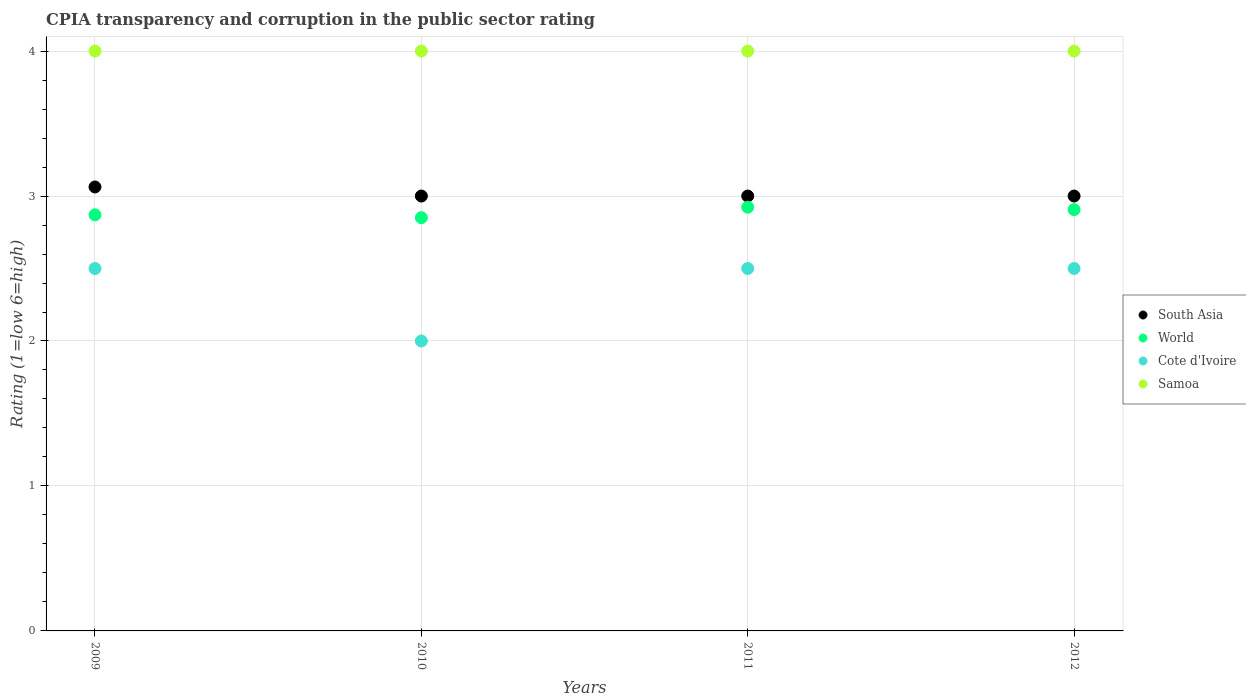What is the CPIA rating in World in 2010?
Your answer should be compact. 2.85. Across all years, what is the maximum CPIA rating in Samoa?
Ensure brevity in your answer.  4. Across all years, what is the minimum CPIA rating in World?
Make the answer very short. 2.85. What is the total CPIA rating in Samoa in the graph?
Your answer should be compact. 16. What is the difference between the CPIA rating in South Asia in 2009 and that in 2012?
Your response must be concise. 0.06. What is the difference between the CPIA rating in South Asia in 2010 and the CPIA rating in World in 2009?
Offer a terse response. 0.13. In the year 2012, what is the difference between the CPIA rating in World and CPIA rating in Cote d'Ivoire?
Your answer should be compact. 0.41. Is the CPIA rating in World in 2009 less than that in 2010?
Your answer should be very brief. No. What is the difference between the highest and the lowest CPIA rating in World?
Offer a terse response. 0.07. In how many years, is the CPIA rating in Cote d'Ivoire greater than the average CPIA rating in Cote d'Ivoire taken over all years?
Offer a very short reply. 3. Is it the case that in every year, the sum of the CPIA rating in Samoa and CPIA rating in World  is greater than the sum of CPIA rating in South Asia and CPIA rating in Cote d'Ivoire?
Ensure brevity in your answer.  Yes. Does the CPIA rating in South Asia monotonically increase over the years?
Offer a very short reply. No. Is the CPIA rating in World strictly greater than the CPIA rating in Cote d'Ivoire over the years?
Provide a succinct answer. Yes. Are the values on the major ticks of Y-axis written in scientific E-notation?
Make the answer very short. No. Does the graph contain any zero values?
Keep it short and to the point. No. What is the title of the graph?
Make the answer very short. CPIA transparency and corruption in the public sector rating. Does "Mongolia" appear as one of the legend labels in the graph?
Provide a succinct answer. No. What is the label or title of the X-axis?
Provide a short and direct response. Years. What is the Rating (1=low 6=high) of South Asia in 2009?
Offer a terse response. 3.06. What is the Rating (1=low 6=high) in World in 2009?
Your answer should be compact. 2.87. What is the Rating (1=low 6=high) of Cote d'Ivoire in 2009?
Ensure brevity in your answer.  2.5. What is the Rating (1=low 6=high) in Samoa in 2009?
Provide a short and direct response. 4. What is the Rating (1=low 6=high) in World in 2010?
Make the answer very short. 2.85. What is the Rating (1=low 6=high) in Samoa in 2010?
Your response must be concise. 4. What is the Rating (1=low 6=high) of World in 2011?
Offer a terse response. 2.92. What is the Rating (1=low 6=high) in Cote d'Ivoire in 2011?
Your response must be concise. 2.5. What is the Rating (1=low 6=high) in South Asia in 2012?
Keep it short and to the point. 3. What is the Rating (1=low 6=high) of World in 2012?
Give a very brief answer. 2.91. What is the Rating (1=low 6=high) of Samoa in 2012?
Offer a terse response. 4. Across all years, what is the maximum Rating (1=low 6=high) in South Asia?
Provide a succinct answer. 3.06. Across all years, what is the maximum Rating (1=low 6=high) of World?
Give a very brief answer. 2.92. Across all years, what is the maximum Rating (1=low 6=high) in Cote d'Ivoire?
Give a very brief answer. 2.5. Across all years, what is the minimum Rating (1=low 6=high) of World?
Your response must be concise. 2.85. What is the total Rating (1=low 6=high) in South Asia in the graph?
Offer a very short reply. 12.06. What is the total Rating (1=low 6=high) in World in the graph?
Ensure brevity in your answer.  11.55. What is the total Rating (1=low 6=high) in Cote d'Ivoire in the graph?
Keep it short and to the point. 9.5. What is the total Rating (1=low 6=high) of Samoa in the graph?
Your response must be concise. 16. What is the difference between the Rating (1=low 6=high) of South Asia in 2009 and that in 2010?
Give a very brief answer. 0.06. What is the difference between the Rating (1=low 6=high) of World in 2009 and that in 2010?
Make the answer very short. 0.02. What is the difference between the Rating (1=low 6=high) in Cote d'Ivoire in 2009 and that in 2010?
Give a very brief answer. 0.5. What is the difference between the Rating (1=low 6=high) of South Asia in 2009 and that in 2011?
Make the answer very short. 0.06. What is the difference between the Rating (1=low 6=high) in World in 2009 and that in 2011?
Provide a short and direct response. -0.05. What is the difference between the Rating (1=low 6=high) of South Asia in 2009 and that in 2012?
Make the answer very short. 0.06. What is the difference between the Rating (1=low 6=high) in World in 2009 and that in 2012?
Offer a terse response. -0.04. What is the difference between the Rating (1=low 6=high) of Samoa in 2009 and that in 2012?
Ensure brevity in your answer.  0. What is the difference between the Rating (1=low 6=high) in World in 2010 and that in 2011?
Your response must be concise. -0.07. What is the difference between the Rating (1=low 6=high) in Cote d'Ivoire in 2010 and that in 2011?
Offer a terse response. -0.5. What is the difference between the Rating (1=low 6=high) of South Asia in 2010 and that in 2012?
Your answer should be very brief. 0. What is the difference between the Rating (1=low 6=high) of World in 2010 and that in 2012?
Your answer should be compact. -0.06. What is the difference between the Rating (1=low 6=high) of World in 2011 and that in 2012?
Provide a short and direct response. 0.02. What is the difference between the Rating (1=low 6=high) in South Asia in 2009 and the Rating (1=low 6=high) in World in 2010?
Offer a very short reply. 0.21. What is the difference between the Rating (1=low 6=high) in South Asia in 2009 and the Rating (1=low 6=high) in Samoa in 2010?
Your answer should be very brief. -0.94. What is the difference between the Rating (1=low 6=high) in World in 2009 and the Rating (1=low 6=high) in Cote d'Ivoire in 2010?
Offer a terse response. 0.87. What is the difference between the Rating (1=low 6=high) in World in 2009 and the Rating (1=low 6=high) in Samoa in 2010?
Offer a very short reply. -1.13. What is the difference between the Rating (1=low 6=high) in South Asia in 2009 and the Rating (1=low 6=high) in World in 2011?
Offer a terse response. 0.14. What is the difference between the Rating (1=low 6=high) in South Asia in 2009 and the Rating (1=low 6=high) in Cote d'Ivoire in 2011?
Provide a short and direct response. 0.56. What is the difference between the Rating (1=low 6=high) in South Asia in 2009 and the Rating (1=low 6=high) in Samoa in 2011?
Provide a short and direct response. -0.94. What is the difference between the Rating (1=low 6=high) of World in 2009 and the Rating (1=low 6=high) of Cote d'Ivoire in 2011?
Provide a succinct answer. 0.37. What is the difference between the Rating (1=low 6=high) of World in 2009 and the Rating (1=low 6=high) of Samoa in 2011?
Provide a short and direct response. -1.13. What is the difference between the Rating (1=low 6=high) of Cote d'Ivoire in 2009 and the Rating (1=low 6=high) of Samoa in 2011?
Offer a very short reply. -1.5. What is the difference between the Rating (1=low 6=high) of South Asia in 2009 and the Rating (1=low 6=high) of World in 2012?
Provide a short and direct response. 0.16. What is the difference between the Rating (1=low 6=high) in South Asia in 2009 and the Rating (1=low 6=high) in Cote d'Ivoire in 2012?
Your answer should be very brief. 0.56. What is the difference between the Rating (1=low 6=high) in South Asia in 2009 and the Rating (1=low 6=high) in Samoa in 2012?
Provide a succinct answer. -0.94. What is the difference between the Rating (1=low 6=high) in World in 2009 and the Rating (1=low 6=high) in Cote d'Ivoire in 2012?
Give a very brief answer. 0.37. What is the difference between the Rating (1=low 6=high) in World in 2009 and the Rating (1=low 6=high) in Samoa in 2012?
Make the answer very short. -1.13. What is the difference between the Rating (1=low 6=high) in Cote d'Ivoire in 2009 and the Rating (1=low 6=high) in Samoa in 2012?
Provide a succinct answer. -1.5. What is the difference between the Rating (1=low 6=high) in South Asia in 2010 and the Rating (1=low 6=high) in World in 2011?
Ensure brevity in your answer.  0.08. What is the difference between the Rating (1=low 6=high) of South Asia in 2010 and the Rating (1=low 6=high) of Cote d'Ivoire in 2011?
Provide a short and direct response. 0.5. What is the difference between the Rating (1=low 6=high) of World in 2010 and the Rating (1=low 6=high) of Cote d'Ivoire in 2011?
Your response must be concise. 0.35. What is the difference between the Rating (1=low 6=high) of World in 2010 and the Rating (1=low 6=high) of Samoa in 2011?
Ensure brevity in your answer.  -1.15. What is the difference between the Rating (1=low 6=high) of South Asia in 2010 and the Rating (1=low 6=high) of World in 2012?
Give a very brief answer. 0.09. What is the difference between the Rating (1=low 6=high) of South Asia in 2010 and the Rating (1=low 6=high) of Cote d'Ivoire in 2012?
Your answer should be very brief. 0.5. What is the difference between the Rating (1=low 6=high) in South Asia in 2010 and the Rating (1=low 6=high) in Samoa in 2012?
Provide a succinct answer. -1. What is the difference between the Rating (1=low 6=high) in World in 2010 and the Rating (1=low 6=high) in Cote d'Ivoire in 2012?
Offer a very short reply. 0.35. What is the difference between the Rating (1=low 6=high) in World in 2010 and the Rating (1=low 6=high) in Samoa in 2012?
Offer a very short reply. -1.15. What is the difference between the Rating (1=low 6=high) of South Asia in 2011 and the Rating (1=low 6=high) of World in 2012?
Give a very brief answer. 0.09. What is the difference between the Rating (1=low 6=high) of South Asia in 2011 and the Rating (1=low 6=high) of Samoa in 2012?
Your response must be concise. -1. What is the difference between the Rating (1=low 6=high) of World in 2011 and the Rating (1=low 6=high) of Cote d'Ivoire in 2012?
Your answer should be very brief. 0.42. What is the difference between the Rating (1=low 6=high) of World in 2011 and the Rating (1=low 6=high) of Samoa in 2012?
Keep it short and to the point. -1.08. What is the average Rating (1=low 6=high) in South Asia per year?
Offer a very short reply. 3.02. What is the average Rating (1=low 6=high) of World per year?
Offer a terse response. 2.89. What is the average Rating (1=low 6=high) in Cote d'Ivoire per year?
Provide a short and direct response. 2.38. In the year 2009, what is the difference between the Rating (1=low 6=high) in South Asia and Rating (1=low 6=high) in World?
Keep it short and to the point. 0.19. In the year 2009, what is the difference between the Rating (1=low 6=high) in South Asia and Rating (1=low 6=high) in Cote d'Ivoire?
Keep it short and to the point. 0.56. In the year 2009, what is the difference between the Rating (1=low 6=high) in South Asia and Rating (1=low 6=high) in Samoa?
Give a very brief answer. -0.94. In the year 2009, what is the difference between the Rating (1=low 6=high) in World and Rating (1=low 6=high) in Cote d'Ivoire?
Offer a terse response. 0.37. In the year 2009, what is the difference between the Rating (1=low 6=high) of World and Rating (1=low 6=high) of Samoa?
Offer a terse response. -1.13. In the year 2010, what is the difference between the Rating (1=low 6=high) of South Asia and Rating (1=low 6=high) of World?
Give a very brief answer. 0.15. In the year 2010, what is the difference between the Rating (1=low 6=high) of South Asia and Rating (1=low 6=high) of Cote d'Ivoire?
Your answer should be very brief. 1. In the year 2010, what is the difference between the Rating (1=low 6=high) of South Asia and Rating (1=low 6=high) of Samoa?
Your response must be concise. -1. In the year 2010, what is the difference between the Rating (1=low 6=high) in World and Rating (1=low 6=high) in Cote d'Ivoire?
Ensure brevity in your answer.  0.85. In the year 2010, what is the difference between the Rating (1=low 6=high) in World and Rating (1=low 6=high) in Samoa?
Keep it short and to the point. -1.15. In the year 2010, what is the difference between the Rating (1=low 6=high) of Cote d'Ivoire and Rating (1=low 6=high) of Samoa?
Offer a terse response. -2. In the year 2011, what is the difference between the Rating (1=low 6=high) of South Asia and Rating (1=low 6=high) of World?
Offer a very short reply. 0.08. In the year 2011, what is the difference between the Rating (1=low 6=high) in South Asia and Rating (1=low 6=high) in Cote d'Ivoire?
Provide a short and direct response. 0.5. In the year 2011, what is the difference between the Rating (1=low 6=high) of South Asia and Rating (1=low 6=high) of Samoa?
Give a very brief answer. -1. In the year 2011, what is the difference between the Rating (1=low 6=high) of World and Rating (1=low 6=high) of Cote d'Ivoire?
Your response must be concise. 0.42. In the year 2011, what is the difference between the Rating (1=low 6=high) in World and Rating (1=low 6=high) in Samoa?
Provide a short and direct response. -1.08. In the year 2011, what is the difference between the Rating (1=low 6=high) of Cote d'Ivoire and Rating (1=low 6=high) of Samoa?
Give a very brief answer. -1.5. In the year 2012, what is the difference between the Rating (1=low 6=high) of South Asia and Rating (1=low 6=high) of World?
Offer a very short reply. 0.09. In the year 2012, what is the difference between the Rating (1=low 6=high) in South Asia and Rating (1=low 6=high) in Samoa?
Your response must be concise. -1. In the year 2012, what is the difference between the Rating (1=low 6=high) of World and Rating (1=low 6=high) of Cote d'Ivoire?
Provide a short and direct response. 0.41. In the year 2012, what is the difference between the Rating (1=low 6=high) in World and Rating (1=low 6=high) in Samoa?
Ensure brevity in your answer.  -1.09. In the year 2012, what is the difference between the Rating (1=low 6=high) in Cote d'Ivoire and Rating (1=low 6=high) in Samoa?
Give a very brief answer. -1.5. What is the ratio of the Rating (1=low 6=high) in South Asia in 2009 to that in 2010?
Give a very brief answer. 1.02. What is the ratio of the Rating (1=low 6=high) of World in 2009 to that in 2010?
Offer a terse response. 1.01. What is the ratio of the Rating (1=low 6=high) in Cote d'Ivoire in 2009 to that in 2010?
Provide a short and direct response. 1.25. What is the ratio of the Rating (1=low 6=high) of South Asia in 2009 to that in 2011?
Offer a terse response. 1.02. What is the ratio of the Rating (1=low 6=high) of World in 2009 to that in 2011?
Provide a short and direct response. 0.98. What is the ratio of the Rating (1=low 6=high) of Samoa in 2009 to that in 2011?
Give a very brief answer. 1. What is the ratio of the Rating (1=low 6=high) in South Asia in 2009 to that in 2012?
Offer a terse response. 1.02. What is the ratio of the Rating (1=low 6=high) of World in 2009 to that in 2012?
Make the answer very short. 0.99. What is the ratio of the Rating (1=low 6=high) in Samoa in 2009 to that in 2012?
Provide a short and direct response. 1. What is the ratio of the Rating (1=low 6=high) of World in 2010 to that in 2011?
Offer a very short reply. 0.98. What is the ratio of the Rating (1=low 6=high) in South Asia in 2010 to that in 2012?
Offer a very short reply. 1. What is the ratio of the Rating (1=low 6=high) of World in 2010 to that in 2012?
Offer a very short reply. 0.98. What is the ratio of the Rating (1=low 6=high) of Cote d'Ivoire in 2010 to that in 2012?
Your answer should be compact. 0.8. What is the ratio of the Rating (1=low 6=high) of Samoa in 2010 to that in 2012?
Make the answer very short. 1. What is the ratio of the Rating (1=low 6=high) in South Asia in 2011 to that in 2012?
Ensure brevity in your answer.  1. What is the ratio of the Rating (1=low 6=high) of Cote d'Ivoire in 2011 to that in 2012?
Provide a short and direct response. 1. What is the difference between the highest and the second highest Rating (1=low 6=high) of South Asia?
Provide a succinct answer. 0.06. What is the difference between the highest and the second highest Rating (1=low 6=high) of World?
Ensure brevity in your answer.  0.02. What is the difference between the highest and the second highest Rating (1=low 6=high) of Samoa?
Give a very brief answer. 0. What is the difference between the highest and the lowest Rating (1=low 6=high) in South Asia?
Your response must be concise. 0.06. What is the difference between the highest and the lowest Rating (1=low 6=high) in World?
Provide a succinct answer. 0.07. What is the difference between the highest and the lowest Rating (1=low 6=high) of Samoa?
Your answer should be compact. 0. 